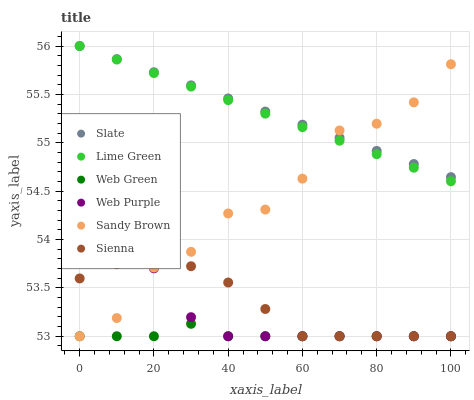Does Web Green have the minimum area under the curve?
Answer yes or no. Yes. Does Slate have the maximum area under the curve?
Answer yes or no. Yes. Does Slate have the minimum area under the curve?
Answer yes or no. No. Does Web Green have the maximum area under the curve?
Answer yes or no. No. Is Slate the smoothest?
Answer yes or no. Yes. Is Sandy Brown the roughest?
Answer yes or no. Yes. Is Web Green the smoothest?
Answer yes or no. No. Is Web Green the roughest?
Answer yes or no. No. Does Web Green have the lowest value?
Answer yes or no. Yes. Does Slate have the lowest value?
Answer yes or no. No. Does Slate have the highest value?
Answer yes or no. Yes. Does Web Green have the highest value?
Answer yes or no. No. Is Web Green less than Slate?
Answer yes or no. Yes. Is Lime Green greater than Web Green?
Answer yes or no. Yes. Does Lime Green intersect Sandy Brown?
Answer yes or no. Yes. Is Lime Green less than Sandy Brown?
Answer yes or no. No. Is Lime Green greater than Sandy Brown?
Answer yes or no. No. Does Web Green intersect Slate?
Answer yes or no. No. 